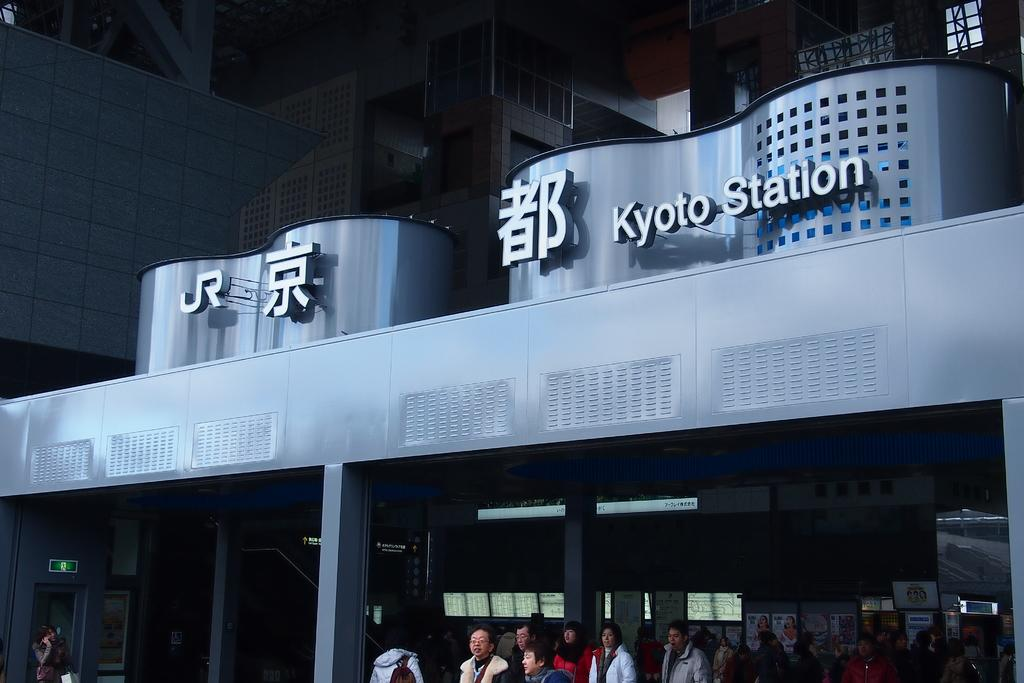What is the location of the persons in the image? The persons are standing on the floor. What can be seen in the background of the image? The persons are near pillars of a building. What is present on the wall of the building? There are hoardings on the wall of the building. What are the hobbies of the mom in the image? There is no mention of a mom or any hobbies in the image. 